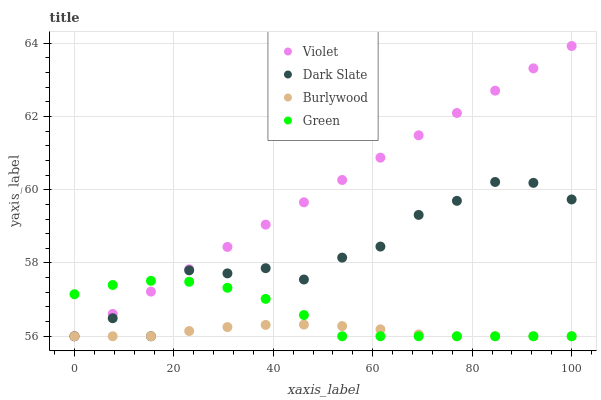Does Burlywood have the minimum area under the curve?
Answer yes or no. Yes. Does Violet have the maximum area under the curve?
Answer yes or no. Yes. Does Dark Slate have the minimum area under the curve?
Answer yes or no. No. Does Dark Slate have the maximum area under the curve?
Answer yes or no. No. Is Violet the smoothest?
Answer yes or no. Yes. Is Dark Slate the roughest?
Answer yes or no. Yes. Is Green the smoothest?
Answer yes or no. No. Is Green the roughest?
Answer yes or no. No. Does Burlywood have the lowest value?
Answer yes or no. Yes. Does Violet have the highest value?
Answer yes or no. Yes. Does Dark Slate have the highest value?
Answer yes or no. No. Does Burlywood intersect Violet?
Answer yes or no. Yes. Is Burlywood less than Violet?
Answer yes or no. No. Is Burlywood greater than Violet?
Answer yes or no. No. 